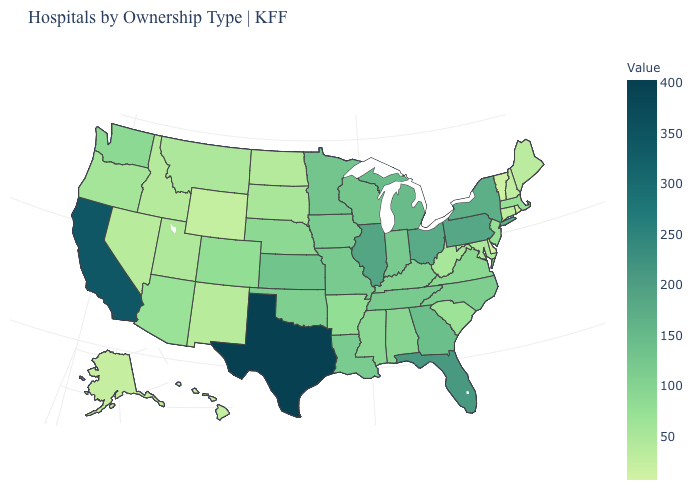Among the states that border Idaho , does Wyoming have the lowest value?
Short answer required. Yes. Is the legend a continuous bar?
Answer briefly. Yes. Among the states that border Wisconsin , does Iowa have the highest value?
Keep it brief. No. Does Kentucky have the lowest value in the South?
Give a very brief answer. No. 